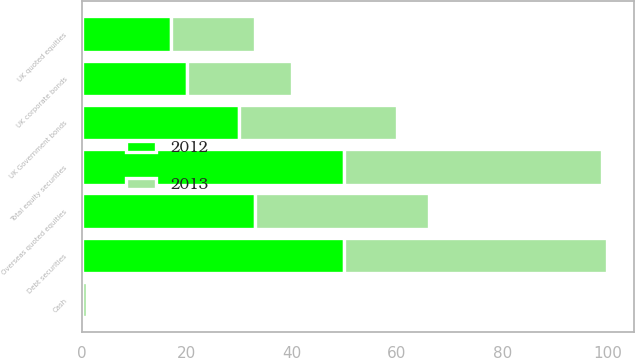<chart> <loc_0><loc_0><loc_500><loc_500><stacked_bar_chart><ecel><fcel>UK quoted equities<fcel>Overseas quoted equities<fcel>Total equity securities<fcel>UK Government bonds<fcel>UK corporate bonds<fcel>Debt securities<fcel>Cash<nl><fcel>2012<fcel>17<fcel>33<fcel>50<fcel>30<fcel>20<fcel>50<fcel>0<nl><fcel>2013<fcel>16<fcel>33<fcel>49<fcel>30<fcel>20<fcel>50<fcel>1<nl></chart> 